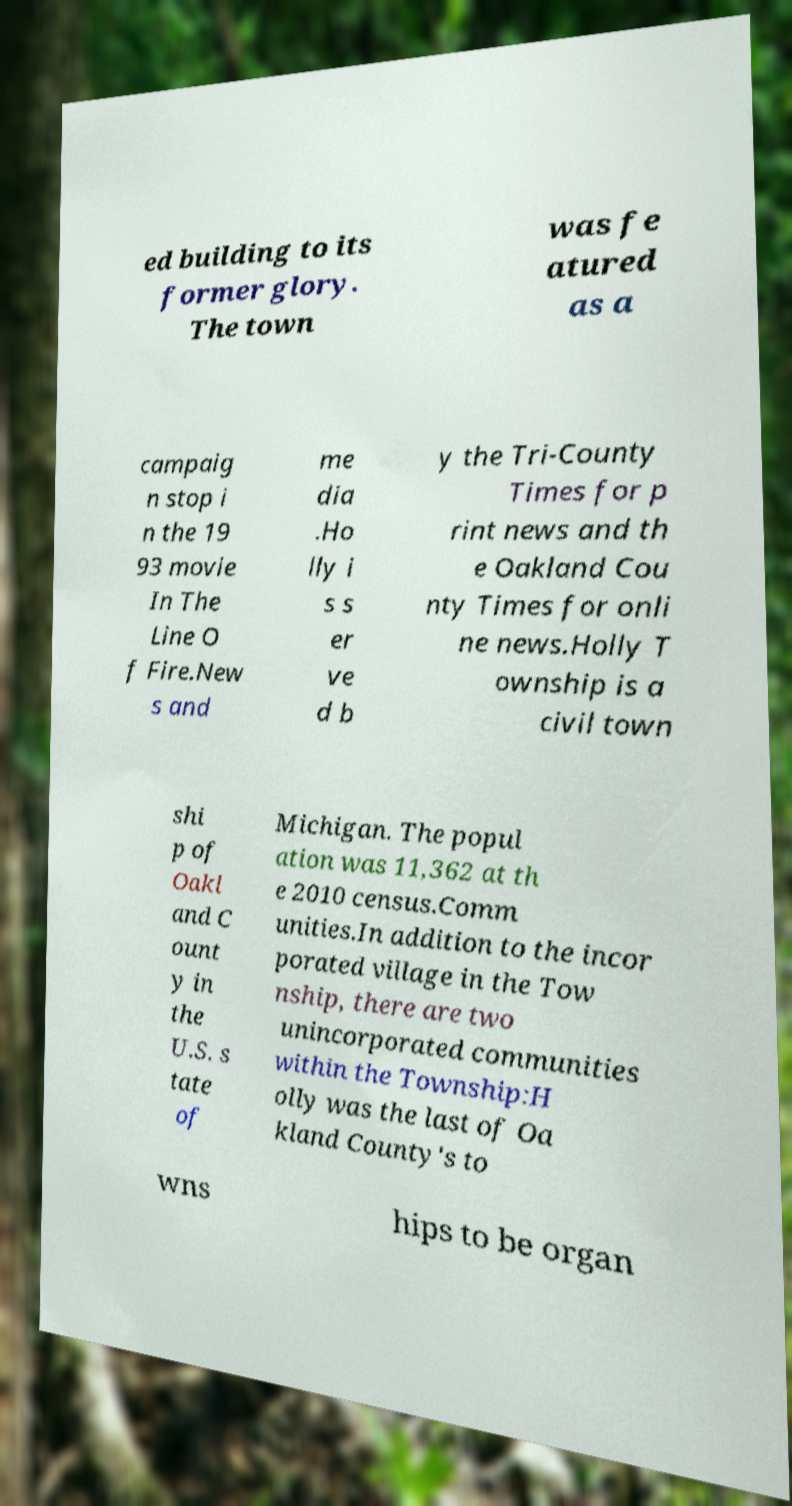I need the written content from this picture converted into text. Can you do that? ed building to its former glory. The town was fe atured as a campaig n stop i n the 19 93 movie In The Line O f Fire.New s and me dia .Ho lly i s s er ve d b y the Tri-County Times for p rint news and th e Oakland Cou nty Times for onli ne news.Holly T ownship is a civil town shi p of Oakl and C ount y in the U.S. s tate of Michigan. The popul ation was 11,362 at th e 2010 census.Comm unities.In addition to the incor porated village in the Tow nship, there are two unincorporated communities within the Township:H olly was the last of Oa kland County's to wns hips to be organ 